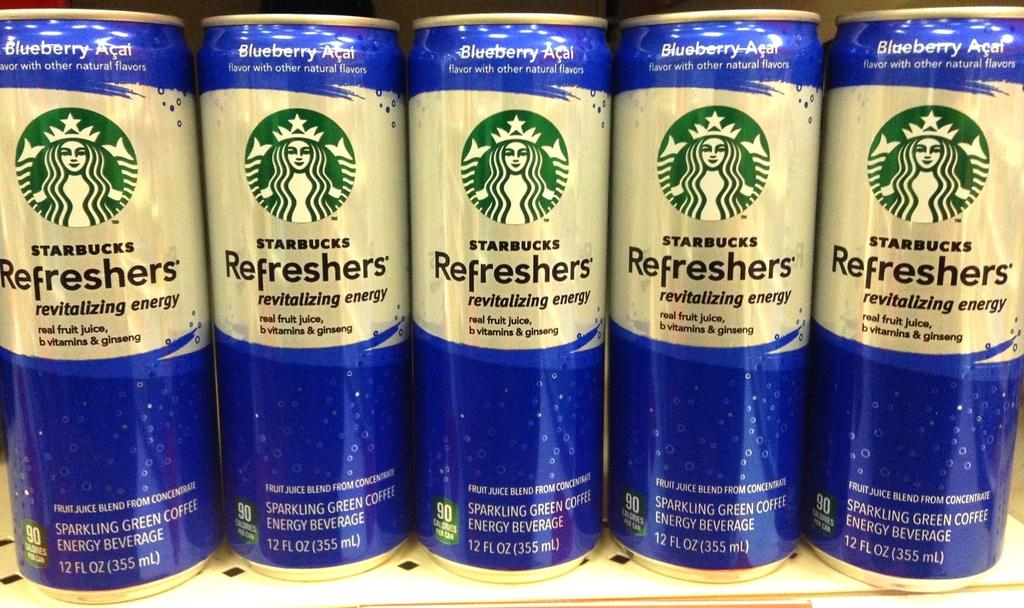<image>
Summarize the visual content of the image. Five cans of a blueberry flavored Starbucks drink stand next to each other. 